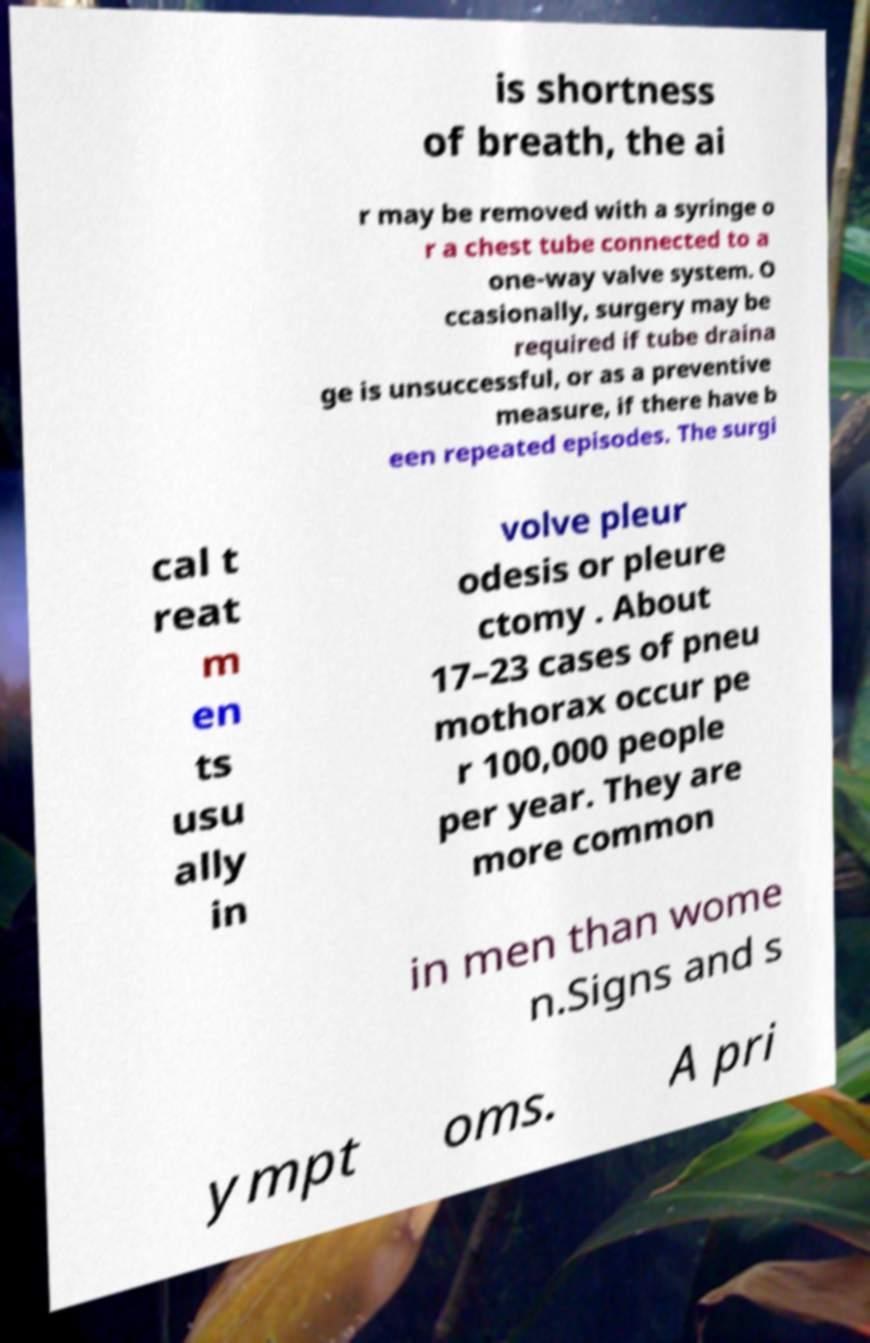Could you assist in decoding the text presented in this image and type it out clearly? is shortness of breath, the ai r may be removed with a syringe o r a chest tube connected to a one-way valve system. O ccasionally, surgery may be required if tube draina ge is unsuccessful, or as a preventive measure, if there have b een repeated episodes. The surgi cal t reat m en ts usu ally in volve pleur odesis or pleure ctomy . About 17–23 cases of pneu mothorax occur pe r 100,000 people per year. They are more common in men than wome n.Signs and s ympt oms. A pri 